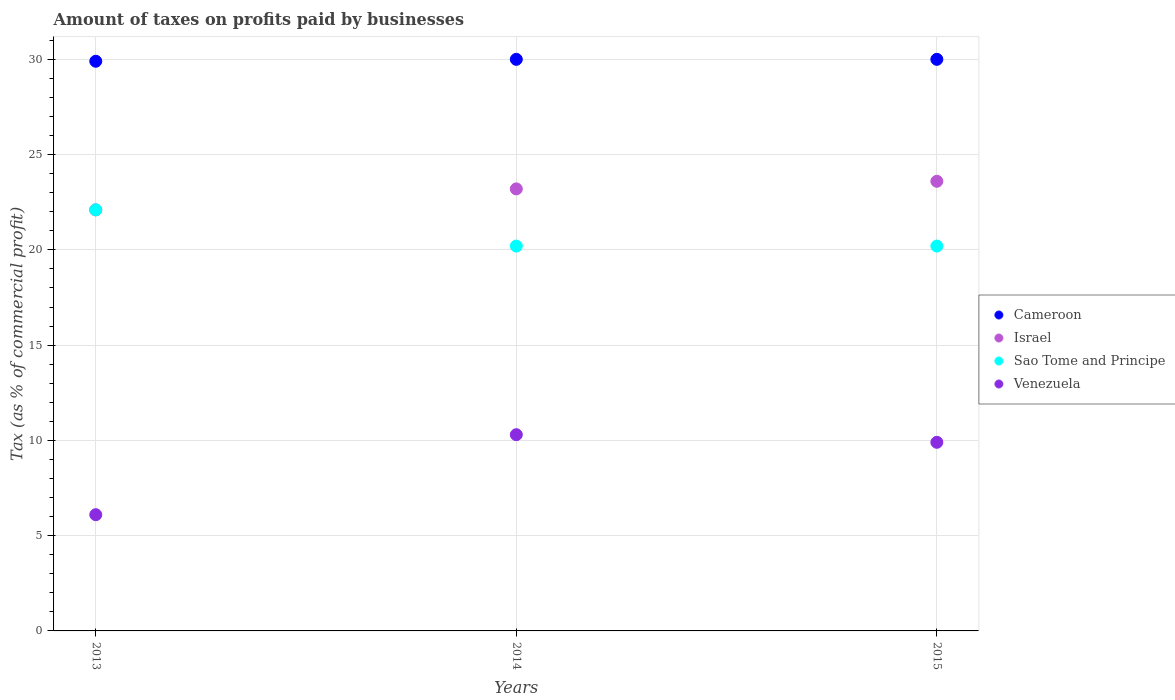How many different coloured dotlines are there?
Your answer should be very brief. 4. What is the percentage of taxes paid by businesses in Venezuela in 2013?
Provide a short and direct response. 6.1. Across all years, what is the maximum percentage of taxes paid by businesses in Israel?
Make the answer very short. 23.6. Across all years, what is the minimum percentage of taxes paid by businesses in Sao Tome and Principe?
Provide a short and direct response. 20.2. In which year was the percentage of taxes paid by businesses in Cameroon minimum?
Ensure brevity in your answer.  2013. What is the total percentage of taxes paid by businesses in Israel in the graph?
Provide a succinct answer. 68.9. What is the difference between the percentage of taxes paid by businesses in Venezuela in 2013 and that in 2014?
Give a very brief answer. -4.2. What is the difference between the percentage of taxes paid by businesses in Cameroon in 2015 and the percentage of taxes paid by businesses in Israel in 2014?
Provide a succinct answer. 6.8. What is the average percentage of taxes paid by businesses in Sao Tome and Principe per year?
Provide a short and direct response. 20.83. In the year 2014, what is the difference between the percentage of taxes paid by businesses in Venezuela and percentage of taxes paid by businesses in Sao Tome and Principe?
Provide a succinct answer. -9.9. Is the percentage of taxes paid by businesses in Cameroon in 2013 less than that in 2015?
Offer a terse response. Yes. Is the difference between the percentage of taxes paid by businesses in Venezuela in 2014 and 2015 greater than the difference between the percentage of taxes paid by businesses in Sao Tome and Principe in 2014 and 2015?
Give a very brief answer. Yes. What is the difference between the highest and the second highest percentage of taxes paid by businesses in Sao Tome and Principe?
Your response must be concise. 1.9. What is the difference between the highest and the lowest percentage of taxes paid by businesses in Israel?
Your response must be concise. 1.5. In how many years, is the percentage of taxes paid by businesses in Venezuela greater than the average percentage of taxes paid by businesses in Venezuela taken over all years?
Offer a very short reply. 2. Is it the case that in every year, the sum of the percentage of taxes paid by businesses in Cameroon and percentage of taxes paid by businesses in Israel  is greater than the sum of percentage of taxes paid by businesses in Sao Tome and Principe and percentage of taxes paid by businesses in Venezuela?
Make the answer very short. Yes. Does the percentage of taxes paid by businesses in Venezuela monotonically increase over the years?
Keep it short and to the point. No. Is the percentage of taxes paid by businesses in Sao Tome and Principe strictly less than the percentage of taxes paid by businesses in Venezuela over the years?
Ensure brevity in your answer.  No. Does the graph contain any zero values?
Ensure brevity in your answer.  No. How many legend labels are there?
Your answer should be compact. 4. How are the legend labels stacked?
Keep it short and to the point. Vertical. What is the title of the graph?
Provide a short and direct response. Amount of taxes on profits paid by businesses. Does "East Asia (developing only)" appear as one of the legend labels in the graph?
Ensure brevity in your answer.  No. What is the label or title of the X-axis?
Offer a terse response. Years. What is the label or title of the Y-axis?
Your answer should be compact. Tax (as % of commercial profit). What is the Tax (as % of commercial profit) of Cameroon in 2013?
Your answer should be very brief. 29.9. What is the Tax (as % of commercial profit) in Israel in 2013?
Provide a short and direct response. 22.1. What is the Tax (as % of commercial profit) in Sao Tome and Principe in 2013?
Give a very brief answer. 22.1. What is the Tax (as % of commercial profit) of Israel in 2014?
Keep it short and to the point. 23.2. What is the Tax (as % of commercial profit) of Sao Tome and Principe in 2014?
Keep it short and to the point. 20.2. What is the Tax (as % of commercial profit) in Venezuela in 2014?
Offer a very short reply. 10.3. What is the Tax (as % of commercial profit) of Cameroon in 2015?
Offer a terse response. 30. What is the Tax (as % of commercial profit) of Israel in 2015?
Keep it short and to the point. 23.6. What is the Tax (as % of commercial profit) of Sao Tome and Principe in 2015?
Ensure brevity in your answer.  20.2. What is the Tax (as % of commercial profit) of Venezuela in 2015?
Provide a short and direct response. 9.9. Across all years, what is the maximum Tax (as % of commercial profit) in Cameroon?
Make the answer very short. 30. Across all years, what is the maximum Tax (as % of commercial profit) in Israel?
Your answer should be compact. 23.6. Across all years, what is the maximum Tax (as % of commercial profit) of Sao Tome and Principe?
Offer a very short reply. 22.1. Across all years, what is the maximum Tax (as % of commercial profit) in Venezuela?
Your response must be concise. 10.3. Across all years, what is the minimum Tax (as % of commercial profit) of Cameroon?
Provide a short and direct response. 29.9. Across all years, what is the minimum Tax (as % of commercial profit) in Israel?
Your response must be concise. 22.1. Across all years, what is the minimum Tax (as % of commercial profit) in Sao Tome and Principe?
Provide a short and direct response. 20.2. What is the total Tax (as % of commercial profit) in Cameroon in the graph?
Your response must be concise. 89.9. What is the total Tax (as % of commercial profit) in Israel in the graph?
Provide a succinct answer. 68.9. What is the total Tax (as % of commercial profit) in Sao Tome and Principe in the graph?
Your answer should be compact. 62.5. What is the total Tax (as % of commercial profit) in Venezuela in the graph?
Make the answer very short. 26.3. What is the difference between the Tax (as % of commercial profit) in Israel in 2013 and that in 2014?
Offer a very short reply. -1.1. What is the difference between the Tax (as % of commercial profit) of Venezuela in 2013 and that in 2015?
Give a very brief answer. -3.8. What is the difference between the Tax (as % of commercial profit) in Venezuela in 2014 and that in 2015?
Offer a terse response. 0.4. What is the difference between the Tax (as % of commercial profit) of Cameroon in 2013 and the Tax (as % of commercial profit) of Venezuela in 2014?
Make the answer very short. 19.6. What is the difference between the Tax (as % of commercial profit) of Israel in 2013 and the Tax (as % of commercial profit) of Sao Tome and Principe in 2014?
Provide a succinct answer. 1.9. What is the difference between the Tax (as % of commercial profit) of Israel in 2013 and the Tax (as % of commercial profit) of Venezuela in 2014?
Offer a very short reply. 11.8. What is the difference between the Tax (as % of commercial profit) in Sao Tome and Principe in 2013 and the Tax (as % of commercial profit) in Venezuela in 2014?
Offer a very short reply. 11.8. What is the difference between the Tax (as % of commercial profit) in Cameroon in 2013 and the Tax (as % of commercial profit) in Israel in 2015?
Your response must be concise. 6.3. What is the difference between the Tax (as % of commercial profit) in Cameroon in 2013 and the Tax (as % of commercial profit) in Sao Tome and Principe in 2015?
Provide a short and direct response. 9.7. What is the difference between the Tax (as % of commercial profit) in Cameroon in 2013 and the Tax (as % of commercial profit) in Venezuela in 2015?
Your response must be concise. 20. What is the difference between the Tax (as % of commercial profit) in Cameroon in 2014 and the Tax (as % of commercial profit) in Israel in 2015?
Keep it short and to the point. 6.4. What is the difference between the Tax (as % of commercial profit) of Cameroon in 2014 and the Tax (as % of commercial profit) of Venezuela in 2015?
Ensure brevity in your answer.  20.1. What is the average Tax (as % of commercial profit) in Cameroon per year?
Your answer should be very brief. 29.97. What is the average Tax (as % of commercial profit) in Israel per year?
Your answer should be compact. 22.97. What is the average Tax (as % of commercial profit) in Sao Tome and Principe per year?
Provide a short and direct response. 20.83. What is the average Tax (as % of commercial profit) of Venezuela per year?
Your response must be concise. 8.77. In the year 2013, what is the difference between the Tax (as % of commercial profit) in Cameroon and Tax (as % of commercial profit) in Israel?
Provide a succinct answer. 7.8. In the year 2013, what is the difference between the Tax (as % of commercial profit) of Cameroon and Tax (as % of commercial profit) of Venezuela?
Provide a short and direct response. 23.8. In the year 2013, what is the difference between the Tax (as % of commercial profit) of Israel and Tax (as % of commercial profit) of Venezuela?
Ensure brevity in your answer.  16. In the year 2014, what is the difference between the Tax (as % of commercial profit) in Cameroon and Tax (as % of commercial profit) in Sao Tome and Principe?
Provide a short and direct response. 9.8. In the year 2014, what is the difference between the Tax (as % of commercial profit) in Israel and Tax (as % of commercial profit) in Sao Tome and Principe?
Make the answer very short. 3. In the year 2014, what is the difference between the Tax (as % of commercial profit) of Israel and Tax (as % of commercial profit) of Venezuela?
Ensure brevity in your answer.  12.9. In the year 2015, what is the difference between the Tax (as % of commercial profit) of Cameroon and Tax (as % of commercial profit) of Israel?
Offer a terse response. 6.4. In the year 2015, what is the difference between the Tax (as % of commercial profit) of Cameroon and Tax (as % of commercial profit) of Venezuela?
Give a very brief answer. 20.1. In the year 2015, what is the difference between the Tax (as % of commercial profit) of Israel and Tax (as % of commercial profit) of Sao Tome and Principe?
Provide a short and direct response. 3.4. In the year 2015, what is the difference between the Tax (as % of commercial profit) of Sao Tome and Principe and Tax (as % of commercial profit) of Venezuela?
Keep it short and to the point. 10.3. What is the ratio of the Tax (as % of commercial profit) of Cameroon in 2013 to that in 2014?
Offer a terse response. 1. What is the ratio of the Tax (as % of commercial profit) in Israel in 2013 to that in 2014?
Your answer should be compact. 0.95. What is the ratio of the Tax (as % of commercial profit) of Sao Tome and Principe in 2013 to that in 2014?
Ensure brevity in your answer.  1.09. What is the ratio of the Tax (as % of commercial profit) in Venezuela in 2013 to that in 2014?
Provide a succinct answer. 0.59. What is the ratio of the Tax (as % of commercial profit) in Israel in 2013 to that in 2015?
Your answer should be very brief. 0.94. What is the ratio of the Tax (as % of commercial profit) in Sao Tome and Principe in 2013 to that in 2015?
Your answer should be compact. 1.09. What is the ratio of the Tax (as % of commercial profit) in Venezuela in 2013 to that in 2015?
Provide a succinct answer. 0.62. What is the ratio of the Tax (as % of commercial profit) in Israel in 2014 to that in 2015?
Give a very brief answer. 0.98. What is the ratio of the Tax (as % of commercial profit) of Sao Tome and Principe in 2014 to that in 2015?
Provide a succinct answer. 1. What is the ratio of the Tax (as % of commercial profit) of Venezuela in 2014 to that in 2015?
Your answer should be very brief. 1.04. What is the difference between the highest and the second highest Tax (as % of commercial profit) in Israel?
Ensure brevity in your answer.  0.4. What is the difference between the highest and the second highest Tax (as % of commercial profit) in Sao Tome and Principe?
Your answer should be very brief. 1.9. What is the difference between the highest and the second highest Tax (as % of commercial profit) in Venezuela?
Your answer should be compact. 0.4. What is the difference between the highest and the lowest Tax (as % of commercial profit) in Sao Tome and Principe?
Make the answer very short. 1.9. 